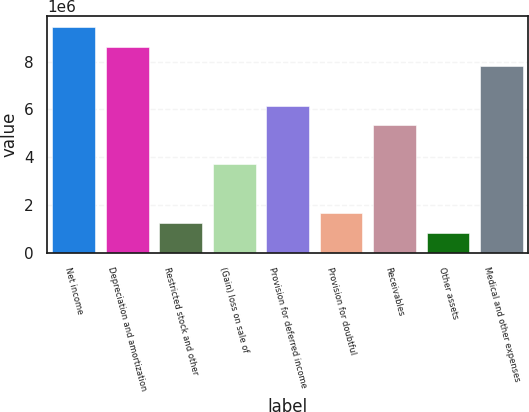Convert chart. <chart><loc_0><loc_0><loc_500><loc_500><bar_chart><fcel>Net income<fcel>Depreciation and amortization<fcel>Restricted stock and other<fcel>(Gain) loss on sale of<fcel>Provision for deferred income<fcel>Provision for doubtful<fcel>Receivables<fcel>Other assets<fcel>Medical and other expenses<nl><fcel>9.44307e+06<fcel>8.62201e+06<fcel>1.23252e+06<fcel>3.69568e+06<fcel>6.15885e+06<fcel>1.64304e+06<fcel>5.33779e+06<fcel>821990<fcel>7.80096e+06<nl></chart> 